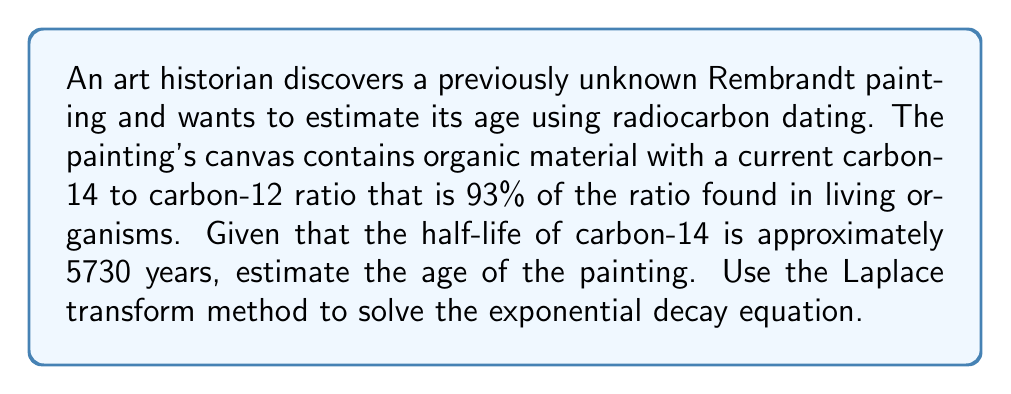Help me with this question. To solve this problem, we'll use the exponential decay equation and the Laplace transform method:

1) The exponential decay equation is:
   $$N(t) = N_0 e^{-\lambda t}$$
   where $N(t)$ is the amount at time $t$, $N_0$ is the initial amount, and $\lambda$ is the decay constant.

2) We're given that the current ratio is 93% of the original, so:
   $$\frac{N(t)}{N_0} = 0.93$$

3) The decay constant $\lambda$ is related to the half-life $T_{1/2}$ by:
   $$\lambda = \frac{\ln(2)}{T_{1/2}} = \frac{0.693}{5730} \approx 1.21 \times 10^{-4} \text{ years}^{-1}$$

4) Substituting into the exponential decay equation:
   $$0.93 = e^{-\lambda t}$$

5) Taking the natural logarithm of both sides:
   $$\ln(0.93) = -\lambda t$$

6) To solve this using Laplace transforms, let's consider the function:
   $$f(t) = e^{-\lambda t}$$

7) The Laplace transform of $f(t)$ is:
   $$F(s) = \mathcal{L}\{f(t)\} = \frac{1}{s + \lambda}$$

8) To find $t$ when $f(t) = 0.93$, we can use the final value theorem:
   $$\lim_{s \to 0} sF(s) = \lim_{t \to \infty} f(t) = 0.93$$

9) Solving this equation:
   $$\frac{s}{s + \lambda} = 0.93$$
   $$s = 0.93s + 0.93\lambda$$
   $$0.07s = 0.93\lambda$$
   $$s = \frac{0.93\lambda}{0.07}$$

10) The time $t$ is the inverse of this $s$ value:
    $$t = \frac{0.07}{0.93\lambda} = \frac{0.07}{0.93 \times 1.21 \times 10^{-4}} \approx 619 \text{ years}$$

Therefore, the estimated age of the painting is approximately 619 years.
Answer: The estimated age of the Rembrandt painting is approximately 619 years. 